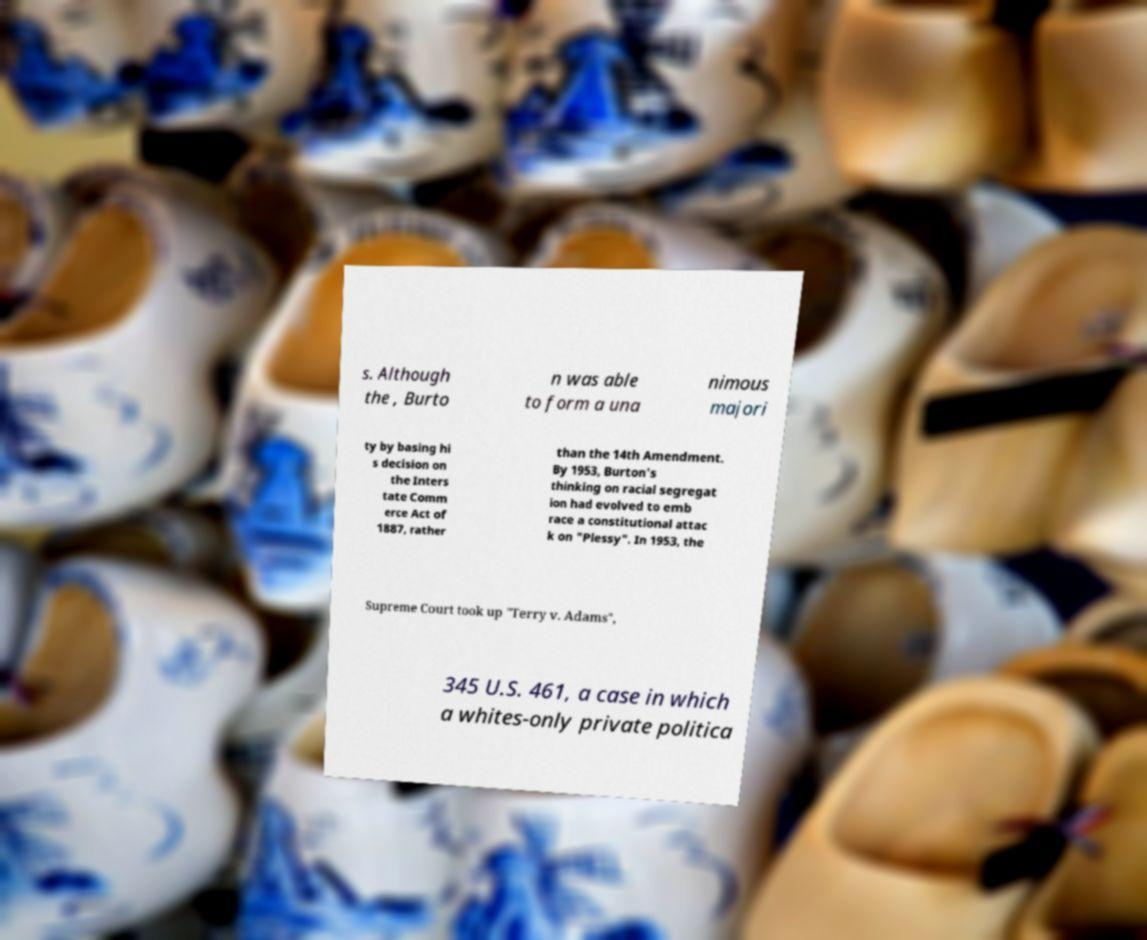Can you accurately transcribe the text from the provided image for me? s. Although the , Burto n was able to form a una nimous majori ty by basing hi s decision on the Inters tate Comm erce Act of 1887, rather than the 14th Amendment. By 1953, Burton's thinking on racial segregat ion had evolved to emb race a constitutional attac k on "Plessy". In 1953, the Supreme Court took up "Terry v. Adams", 345 U.S. 461, a case in which a whites-only private politica 